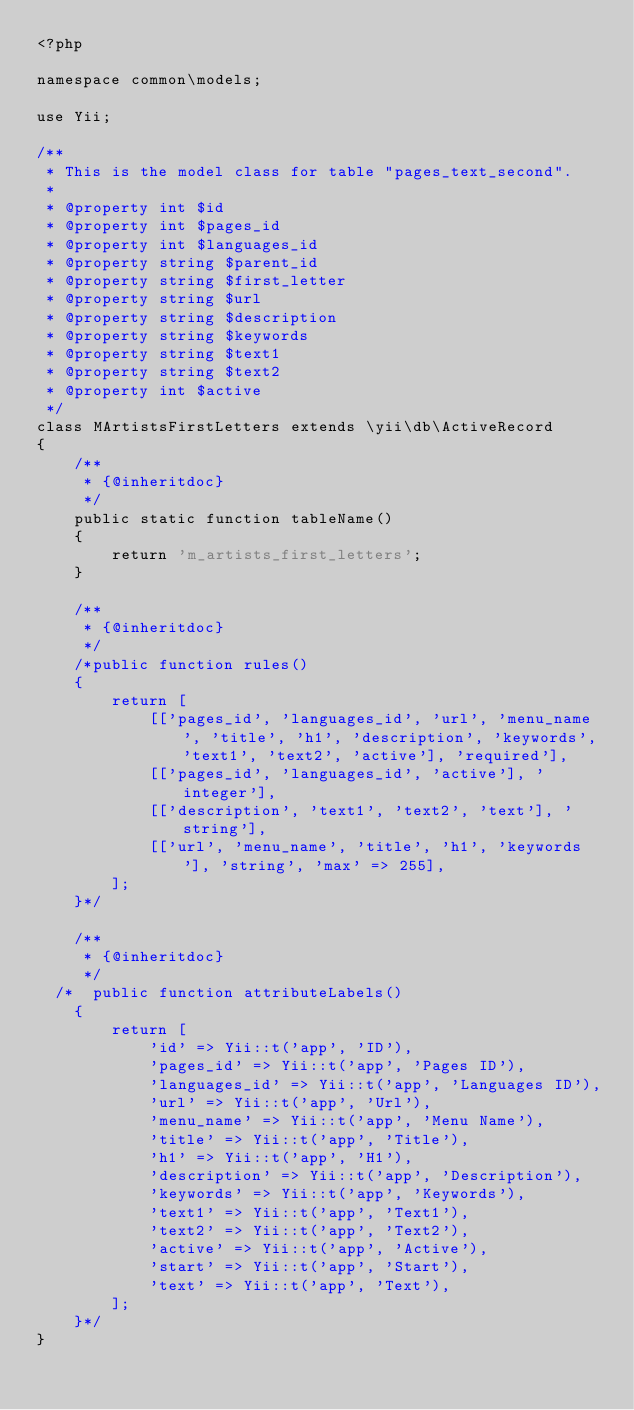Convert code to text. <code><loc_0><loc_0><loc_500><loc_500><_PHP_><?php

namespace common\models;

use Yii;

/**
 * This is the model class for table "pages_text_second".
 *
 * @property int $id
 * @property int $pages_id
 * @property int $languages_id
 * @property string $parent_id
 * @property string $first_letter
 * @property string $url
 * @property string $description
 * @property string $keywords
 * @property string $text1
 * @property string $text2
 * @property int $active
 */
class MArtistsFirstLetters extends \yii\db\ActiveRecord
{
    /**
     * {@inheritdoc}
     */
    public static function tableName()
    {
        return 'm_artists_first_letters';
    }

    /**
     * {@inheritdoc}
     */
    /*public function rules()
    {
        return [
            [['pages_id', 'languages_id', 'url', 'menu_name', 'title', 'h1', 'description', 'keywords', 'text1', 'text2', 'active'], 'required'],
            [['pages_id', 'languages_id', 'active'], 'integer'],
            [['description', 'text1', 'text2', 'text'], 'string'],
            [['url', 'menu_name', 'title', 'h1', 'keywords'], 'string', 'max' => 255],
        ];
    }*/

    /**
     * {@inheritdoc}
     */
  /*  public function attributeLabels()
    {
        return [
            'id' => Yii::t('app', 'ID'),
            'pages_id' => Yii::t('app', 'Pages ID'),
            'languages_id' => Yii::t('app', 'Languages ID'),
            'url' => Yii::t('app', 'Url'),
            'menu_name' => Yii::t('app', 'Menu Name'),
            'title' => Yii::t('app', 'Title'),
            'h1' => Yii::t('app', 'H1'),
            'description' => Yii::t('app', 'Description'),
            'keywords' => Yii::t('app', 'Keywords'),
            'text1' => Yii::t('app', 'Text1'),
            'text2' => Yii::t('app', 'Text2'),
            'active' => Yii::t('app', 'Active'),
            'start' => Yii::t('app', 'Start'),
            'text' => Yii::t('app', 'Text'),
        ];
    }*/
}
</code> 